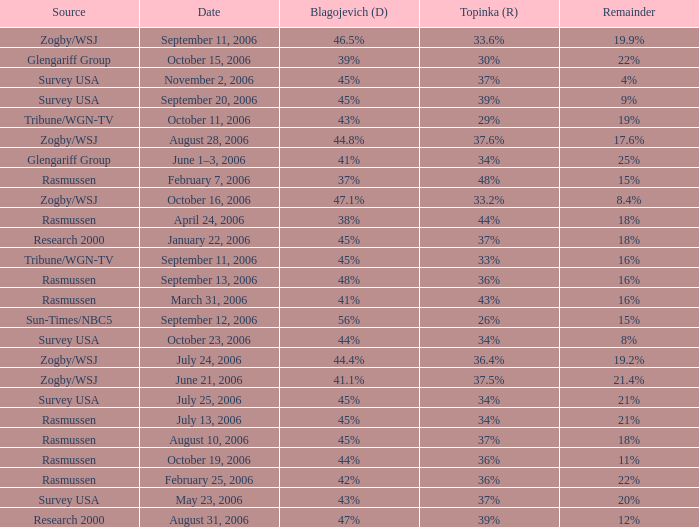Could you help me parse every detail presented in this table? {'header': ['Source', 'Date', 'Blagojevich (D)', 'Topinka (R)', 'Remainder'], 'rows': [['Zogby/WSJ', 'September 11, 2006', '46.5%', '33.6%', '19.9%'], ['Glengariff Group', 'October 15, 2006', '39%', '30%', '22%'], ['Survey USA', 'November 2, 2006', '45%', '37%', '4%'], ['Survey USA', 'September 20, 2006', '45%', '39%', '9%'], ['Tribune/WGN-TV', 'October 11, 2006', '43%', '29%', '19%'], ['Zogby/WSJ', 'August 28, 2006', '44.8%', '37.6%', '17.6%'], ['Glengariff Group', 'June 1–3, 2006', '41%', '34%', '25%'], ['Rasmussen', 'February 7, 2006', '37%', '48%', '15%'], ['Zogby/WSJ', 'October 16, 2006', '47.1%', '33.2%', '8.4%'], ['Rasmussen', 'April 24, 2006', '38%', '44%', '18%'], ['Research 2000', 'January 22, 2006', '45%', '37%', '18%'], ['Tribune/WGN-TV', 'September 11, 2006', '45%', '33%', '16%'], ['Rasmussen', 'September 13, 2006', '48%', '36%', '16%'], ['Rasmussen', 'March 31, 2006', '41%', '43%', '16%'], ['Sun-Times/NBC5', 'September 12, 2006', '56%', '26%', '15%'], ['Survey USA', 'October 23, 2006', '44%', '34%', '8%'], ['Zogby/WSJ', 'July 24, 2006', '44.4%', '36.4%', '19.2%'], ['Zogby/WSJ', 'June 21, 2006', '41.1%', '37.5%', '21.4%'], ['Survey USA', 'July 25, 2006', '45%', '34%', '21%'], ['Rasmussen', 'July 13, 2006', '45%', '34%', '21%'], ['Rasmussen', 'August 10, 2006', '45%', '37%', '18%'], ['Rasmussen', 'October 19, 2006', '44%', '36%', '11%'], ['Rasmussen', 'February 25, 2006', '42%', '36%', '22%'], ['Survey USA', 'May 23, 2006', '43%', '37%', '20%'], ['Research 2000', 'August 31, 2006', '47%', '39%', '12%']]} Which Topinka happened on january 22, 2006? 37%. 